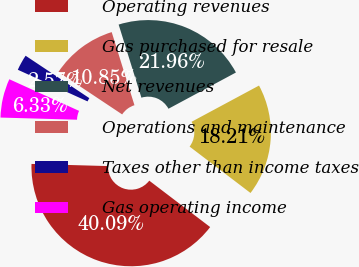Convert chart to OTSL. <chart><loc_0><loc_0><loc_500><loc_500><pie_chart><fcel>Operating revenues<fcel>Gas purchased for resale<fcel>Net revenues<fcel>Operations and maintenance<fcel>Taxes other than income taxes<fcel>Gas operating income<nl><fcel>40.09%<fcel>18.21%<fcel>21.96%<fcel>10.85%<fcel>2.57%<fcel>6.33%<nl></chart> 